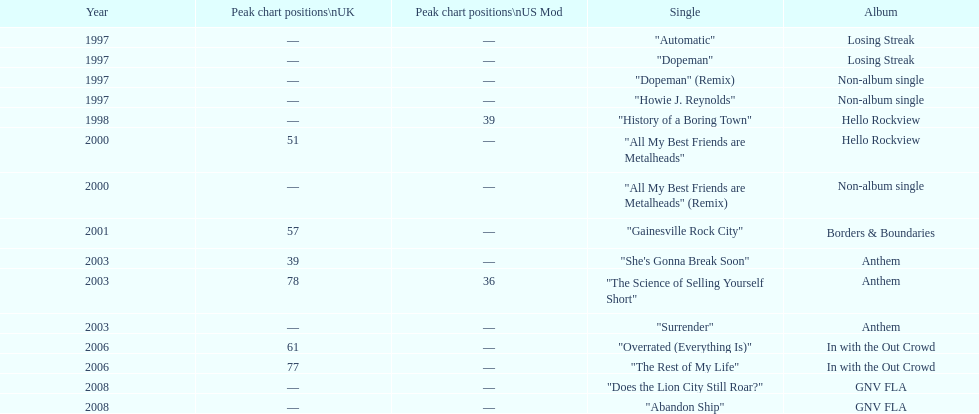Which single was released before "dopeman"? "Automatic". 